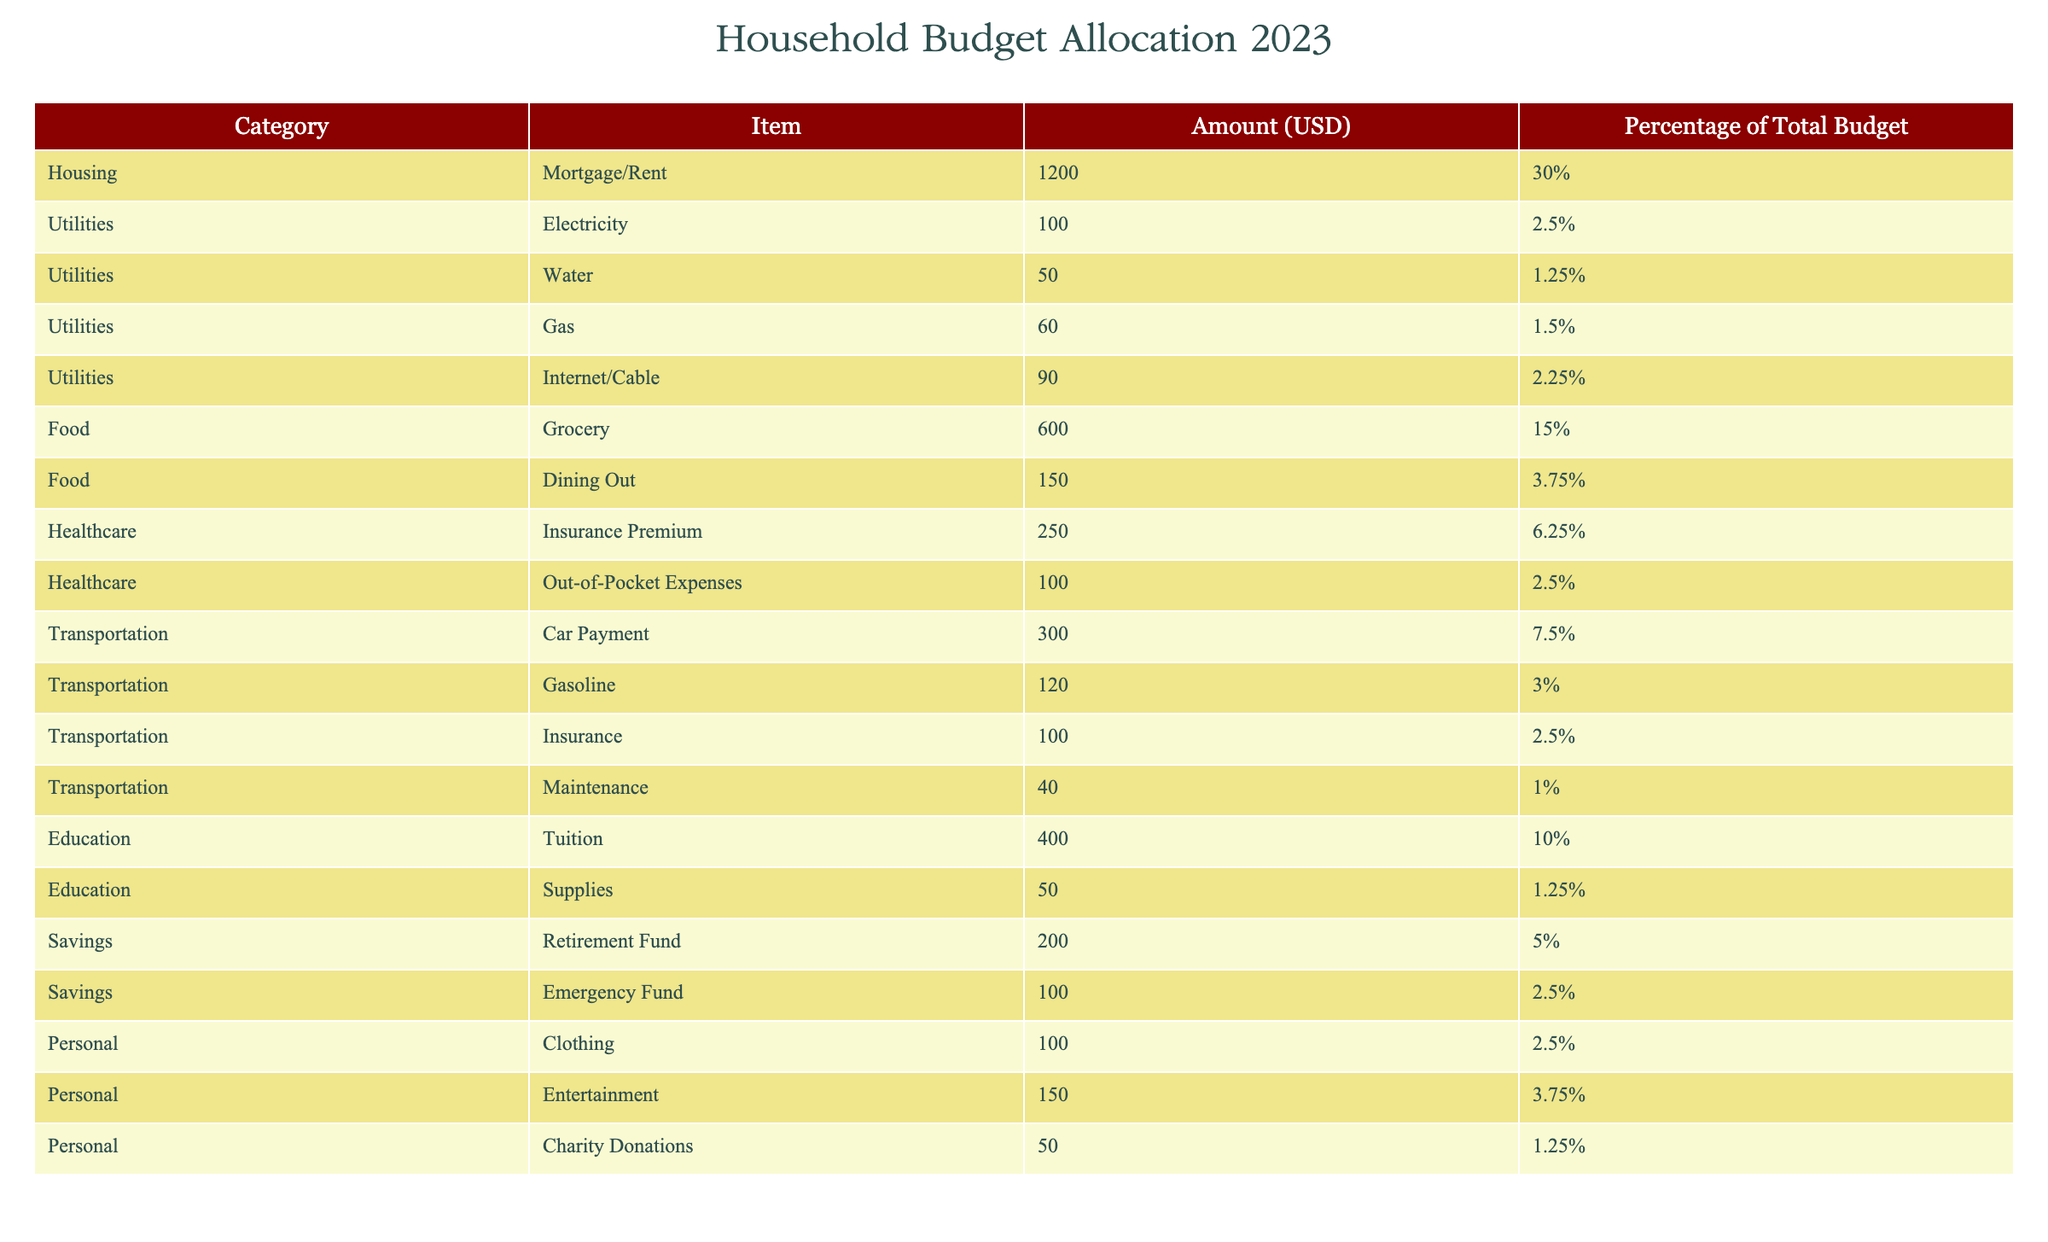What is the total amount allocated to Housing? To find the total amount allocated to Housing, we look at the specific item under the Housing category, which is Mortgage/Rent. The amount listed is 1200 USD.
Answer: 1200 USD What percentage of the total budget is allocated to Utilities? The Utilities category has four items: Electricity (2.5%), Water (1.25%), Gas (1.5%), and Internet/Cable (2.25%). Adding these percentages together: 2.5 + 1.25 + 1.5 + 2.25 = 7.5%.
Answer: 7.5% Is the amount spent on Food greater than the amount spent on Healthcare? The total amount for Food is 600 (Grocery) + 150 (Dining Out) = 750 USD. For Healthcare, it is 250 (Insurance Premium) + 100 (Out-of-Pocket Expenses) = 350 USD. Since 750 is greater than 350, the answer is yes.
Answer: Yes What is the total percentage allocated to Savings? The Savings category has two items: Retirement Fund (5%) and Emergency Fund (2.5%). Adding these percentages together gives us: 5% + 2.5% = 7.5%.
Answer: 7.5% Which category has the highest single expenditure in the budget? The highest single expenditure is in the Housing category with the Mortgage/Rent item, which is 1200 USD. We can compare all categories and find that no other item exceeds this amount.
Answer: Housing What is the average expenditure on Transportation? Transportation includes four items: Car Payment (300 USD), Gasoline (120 USD), Insurance (100 USD), and Maintenance (40 USD). The total expenditure is: 300 + 120 + 100 + 40 = 560 USD. There are four items, so the average is 560/4 = 140 USD.
Answer: 140 USD Does the sum of Charity Donations and Entertainment exceed the amount spent on Utilities? Charity Donations is 50 USD and Entertainment is 150 USD. Their total is 50 + 150 = 200 USD. The total expenditure on Utilities is 7.5% of the budget (we can compute that, but we see it does not meet Utilities). 200 USD does exceed 150. So the answer is no.
Answer: No What is the total expenditure on Food and Education combined? Food totals to 600 (Grocery) + 150 (Dining Out) = 750 USD. Education totals to 400 (Tuition) + 50 (Supplies) = 450 USD. Therefore, the combined amount is 750 + 450 = 1200 USD.
Answer: 1200 USD What is the expenditure on Healthcare as a percentage of the total budget? Healthcare includes Insurance Premium (250 USD) and Out-of-Pocket Expenses (100 USD). The total for Healthcare is 250 + 100 = 350 USD. To find the percentage of the total budget, we take (350 / 4000) * 100% (assuming 4000 is total from percentages). So it becomes 8.75%.
Answer: 8.75% 